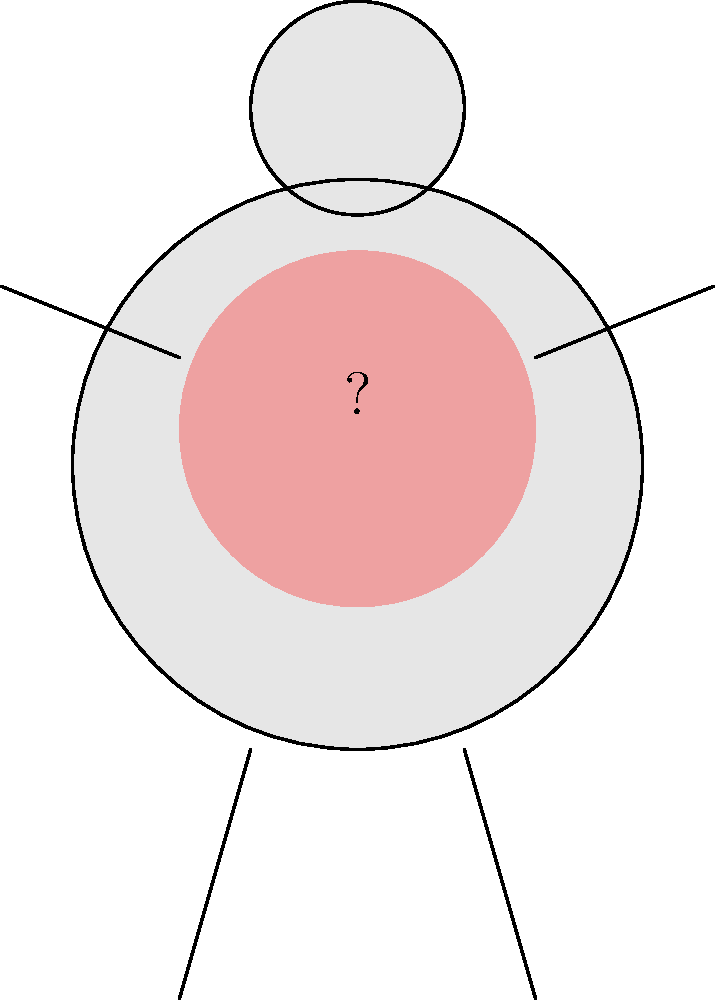A 65-year-old patient presents with persistent cough, shortness of breath, and wheezing. Based on the highlighted area in the body diagram, which chronic disease should be primarily considered? To identify the chronic disease based on the symptoms and highlighted area:

1. Analyze the symptoms:
   - Persistent cough
   - Shortness of breath
   - Wheezing

2. Observe the highlighted area:
   - The red shaded area is in the chest region, indicating involvement of the lungs.

3. Consider common chronic diseases affecting the lungs:
   - Chronic Obstructive Pulmonary Disease (COPD)
   - Asthma
   - Interstitial Lung Disease

4. Match symptoms with diseases:
   - COPD typically presents with persistent cough, shortness of breath, and wheezing.
   - It's more common in older adults (patient is 65 years old).
   - COPD primarily affects the lungs, which aligns with the highlighted area.

5. Rule out other possibilities:
   - Asthma is less likely due to the patient's age and persistent nature of symptoms.
   - Interstitial Lung Disease usually presents with dry cough and doesn't typically cause wheezing.

Therefore, based on the patient's age, symptoms, and the highlighted lung area, Chronic Obstructive Pulmonary Disease (COPD) should be primarily considered.
Answer: Chronic Obstructive Pulmonary Disease (COPD) 